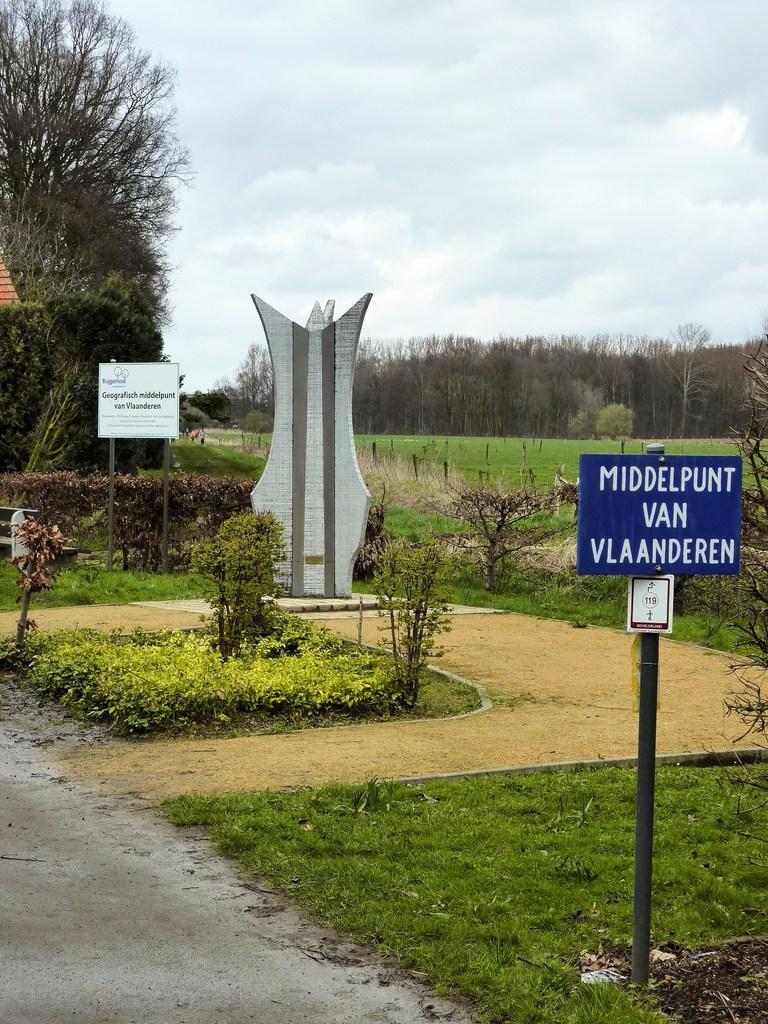Can you describe this image briefly? In this image we can see a statue, there are some trees, poles, grass, plants and boards, on the boards, we can see some text and in the background, we can see the sky with clouds. 